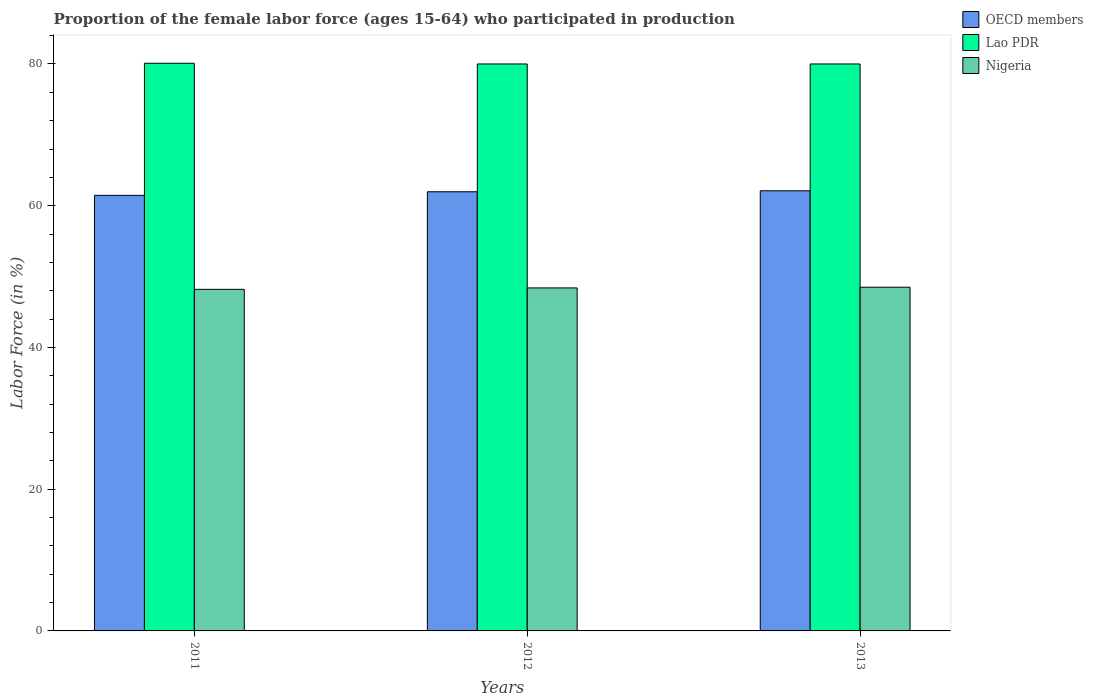How many different coloured bars are there?
Your answer should be very brief. 3. How many groups of bars are there?
Your response must be concise. 3. Are the number of bars per tick equal to the number of legend labels?
Offer a very short reply. Yes. How many bars are there on the 3rd tick from the left?
Give a very brief answer. 3. What is the label of the 1st group of bars from the left?
Your response must be concise. 2011. In how many cases, is the number of bars for a given year not equal to the number of legend labels?
Provide a succinct answer. 0. What is the proportion of the female labor force who participated in production in OECD members in 2013?
Your answer should be compact. 62.11. Across all years, what is the maximum proportion of the female labor force who participated in production in Lao PDR?
Your answer should be very brief. 80.1. Across all years, what is the minimum proportion of the female labor force who participated in production in OECD members?
Your answer should be compact. 61.46. In which year was the proportion of the female labor force who participated in production in Nigeria maximum?
Provide a short and direct response. 2013. In which year was the proportion of the female labor force who participated in production in Nigeria minimum?
Provide a succinct answer. 2011. What is the total proportion of the female labor force who participated in production in Lao PDR in the graph?
Ensure brevity in your answer.  240.1. What is the difference between the proportion of the female labor force who participated in production in Lao PDR in 2011 and that in 2012?
Give a very brief answer. 0.1. What is the difference between the proportion of the female labor force who participated in production in Lao PDR in 2012 and the proportion of the female labor force who participated in production in Nigeria in 2013?
Keep it short and to the point. 31.5. What is the average proportion of the female labor force who participated in production in Nigeria per year?
Provide a short and direct response. 48.37. In the year 2011, what is the difference between the proportion of the female labor force who participated in production in OECD members and proportion of the female labor force who participated in production in Nigeria?
Provide a succinct answer. 13.26. In how many years, is the proportion of the female labor force who participated in production in Nigeria greater than 16 %?
Offer a very short reply. 3. What is the ratio of the proportion of the female labor force who participated in production in Nigeria in 2011 to that in 2012?
Provide a succinct answer. 1. Is the proportion of the female labor force who participated in production in Lao PDR in 2011 less than that in 2013?
Your response must be concise. No. What is the difference between the highest and the second highest proportion of the female labor force who participated in production in OECD members?
Provide a short and direct response. 0.14. What is the difference between the highest and the lowest proportion of the female labor force who participated in production in Nigeria?
Offer a very short reply. 0.3. In how many years, is the proportion of the female labor force who participated in production in Nigeria greater than the average proportion of the female labor force who participated in production in Nigeria taken over all years?
Offer a very short reply. 2. Is the sum of the proportion of the female labor force who participated in production in Lao PDR in 2012 and 2013 greater than the maximum proportion of the female labor force who participated in production in Nigeria across all years?
Your answer should be compact. Yes. What does the 1st bar from the left in 2011 represents?
Your answer should be very brief. OECD members. What does the 3rd bar from the right in 2013 represents?
Your response must be concise. OECD members. Is it the case that in every year, the sum of the proportion of the female labor force who participated in production in Nigeria and proportion of the female labor force who participated in production in Lao PDR is greater than the proportion of the female labor force who participated in production in OECD members?
Ensure brevity in your answer.  Yes. How many years are there in the graph?
Give a very brief answer. 3. What is the difference between two consecutive major ticks on the Y-axis?
Your answer should be very brief. 20. Are the values on the major ticks of Y-axis written in scientific E-notation?
Your response must be concise. No. Does the graph contain any zero values?
Offer a very short reply. No. Does the graph contain grids?
Your response must be concise. No. How are the legend labels stacked?
Keep it short and to the point. Vertical. What is the title of the graph?
Offer a very short reply. Proportion of the female labor force (ages 15-64) who participated in production. Does "Marshall Islands" appear as one of the legend labels in the graph?
Offer a very short reply. No. What is the label or title of the X-axis?
Provide a short and direct response. Years. What is the label or title of the Y-axis?
Give a very brief answer. Labor Force (in %). What is the Labor Force (in %) of OECD members in 2011?
Make the answer very short. 61.46. What is the Labor Force (in %) in Lao PDR in 2011?
Offer a terse response. 80.1. What is the Labor Force (in %) in Nigeria in 2011?
Provide a short and direct response. 48.2. What is the Labor Force (in %) in OECD members in 2012?
Keep it short and to the point. 61.97. What is the Labor Force (in %) in Nigeria in 2012?
Your answer should be compact. 48.4. What is the Labor Force (in %) in OECD members in 2013?
Ensure brevity in your answer.  62.11. What is the Labor Force (in %) of Lao PDR in 2013?
Give a very brief answer. 80. What is the Labor Force (in %) in Nigeria in 2013?
Give a very brief answer. 48.5. Across all years, what is the maximum Labor Force (in %) in OECD members?
Provide a short and direct response. 62.11. Across all years, what is the maximum Labor Force (in %) of Lao PDR?
Your answer should be compact. 80.1. Across all years, what is the maximum Labor Force (in %) of Nigeria?
Your answer should be compact. 48.5. Across all years, what is the minimum Labor Force (in %) of OECD members?
Offer a terse response. 61.46. Across all years, what is the minimum Labor Force (in %) in Nigeria?
Offer a very short reply. 48.2. What is the total Labor Force (in %) in OECD members in the graph?
Give a very brief answer. 185.53. What is the total Labor Force (in %) of Lao PDR in the graph?
Keep it short and to the point. 240.1. What is the total Labor Force (in %) of Nigeria in the graph?
Give a very brief answer. 145.1. What is the difference between the Labor Force (in %) of OECD members in 2011 and that in 2012?
Make the answer very short. -0.51. What is the difference between the Labor Force (in %) in OECD members in 2011 and that in 2013?
Your answer should be very brief. -0.65. What is the difference between the Labor Force (in %) of OECD members in 2012 and that in 2013?
Make the answer very short. -0.14. What is the difference between the Labor Force (in %) of Lao PDR in 2012 and that in 2013?
Your response must be concise. 0. What is the difference between the Labor Force (in %) of OECD members in 2011 and the Labor Force (in %) of Lao PDR in 2012?
Your answer should be very brief. -18.54. What is the difference between the Labor Force (in %) of OECD members in 2011 and the Labor Force (in %) of Nigeria in 2012?
Give a very brief answer. 13.06. What is the difference between the Labor Force (in %) in Lao PDR in 2011 and the Labor Force (in %) in Nigeria in 2012?
Give a very brief answer. 31.7. What is the difference between the Labor Force (in %) of OECD members in 2011 and the Labor Force (in %) of Lao PDR in 2013?
Make the answer very short. -18.54. What is the difference between the Labor Force (in %) in OECD members in 2011 and the Labor Force (in %) in Nigeria in 2013?
Give a very brief answer. 12.96. What is the difference between the Labor Force (in %) of Lao PDR in 2011 and the Labor Force (in %) of Nigeria in 2013?
Your answer should be very brief. 31.6. What is the difference between the Labor Force (in %) in OECD members in 2012 and the Labor Force (in %) in Lao PDR in 2013?
Your answer should be very brief. -18.03. What is the difference between the Labor Force (in %) in OECD members in 2012 and the Labor Force (in %) in Nigeria in 2013?
Your answer should be very brief. 13.47. What is the difference between the Labor Force (in %) in Lao PDR in 2012 and the Labor Force (in %) in Nigeria in 2013?
Keep it short and to the point. 31.5. What is the average Labor Force (in %) of OECD members per year?
Your answer should be very brief. 61.84. What is the average Labor Force (in %) of Lao PDR per year?
Your answer should be very brief. 80.03. What is the average Labor Force (in %) in Nigeria per year?
Offer a very short reply. 48.37. In the year 2011, what is the difference between the Labor Force (in %) of OECD members and Labor Force (in %) of Lao PDR?
Your answer should be very brief. -18.64. In the year 2011, what is the difference between the Labor Force (in %) of OECD members and Labor Force (in %) of Nigeria?
Provide a succinct answer. 13.26. In the year 2011, what is the difference between the Labor Force (in %) of Lao PDR and Labor Force (in %) of Nigeria?
Keep it short and to the point. 31.9. In the year 2012, what is the difference between the Labor Force (in %) in OECD members and Labor Force (in %) in Lao PDR?
Keep it short and to the point. -18.03. In the year 2012, what is the difference between the Labor Force (in %) of OECD members and Labor Force (in %) of Nigeria?
Give a very brief answer. 13.57. In the year 2012, what is the difference between the Labor Force (in %) in Lao PDR and Labor Force (in %) in Nigeria?
Provide a short and direct response. 31.6. In the year 2013, what is the difference between the Labor Force (in %) of OECD members and Labor Force (in %) of Lao PDR?
Provide a short and direct response. -17.89. In the year 2013, what is the difference between the Labor Force (in %) in OECD members and Labor Force (in %) in Nigeria?
Your answer should be very brief. 13.61. In the year 2013, what is the difference between the Labor Force (in %) in Lao PDR and Labor Force (in %) in Nigeria?
Ensure brevity in your answer.  31.5. What is the ratio of the Labor Force (in %) in OECD members in 2011 to that in 2012?
Give a very brief answer. 0.99. What is the ratio of the Labor Force (in %) in Lao PDR in 2011 to that in 2012?
Your answer should be very brief. 1. What is the ratio of the Labor Force (in %) of OECD members in 2011 to that in 2013?
Provide a short and direct response. 0.99. What is the ratio of the Labor Force (in %) in OECD members in 2012 to that in 2013?
Your response must be concise. 1. What is the ratio of the Labor Force (in %) of Lao PDR in 2012 to that in 2013?
Keep it short and to the point. 1. What is the ratio of the Labor Force (in %) in Nigeria in 2012 to that in 2013?
Ensure brevity in your answer.  1. What is the difference between the highest and the second highest Labor Force (in %) of OECD members?
Give a very brief answer. 0.14. What is the difference between the highest and the second highest Labor Force (in %) of Lao PDR?
Ensure brevity in your answer.  0.1. What is the difference between the highest and the lowest Labor Force (in %) in OECD members?
Your response must be concise. 0.65. What is the difference between the highest and the lowest Labor Force (in %) in Lao PDR?
Your answer should be very brief. 0.1. What is the difference between the highest and the lowest Labor Force (in %) of Nigeria?
Offer a very short reply. 0.3. 